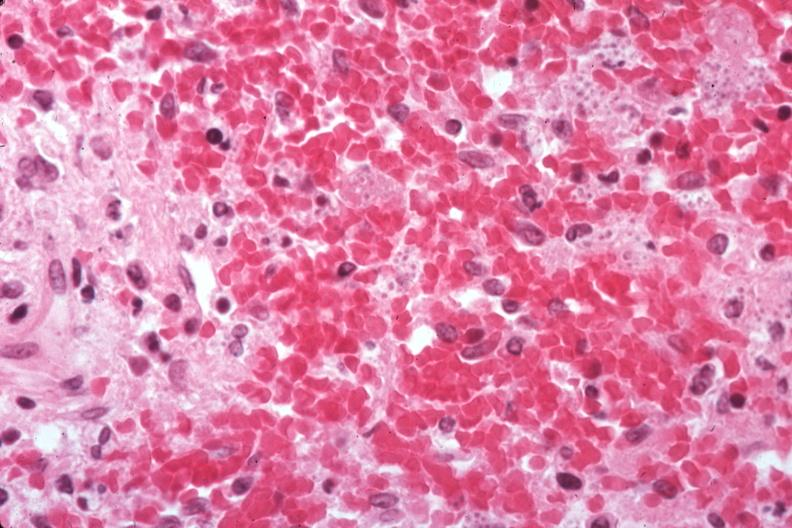what is present?
Answer the question using a single word or phrase. Histoplasmosis 